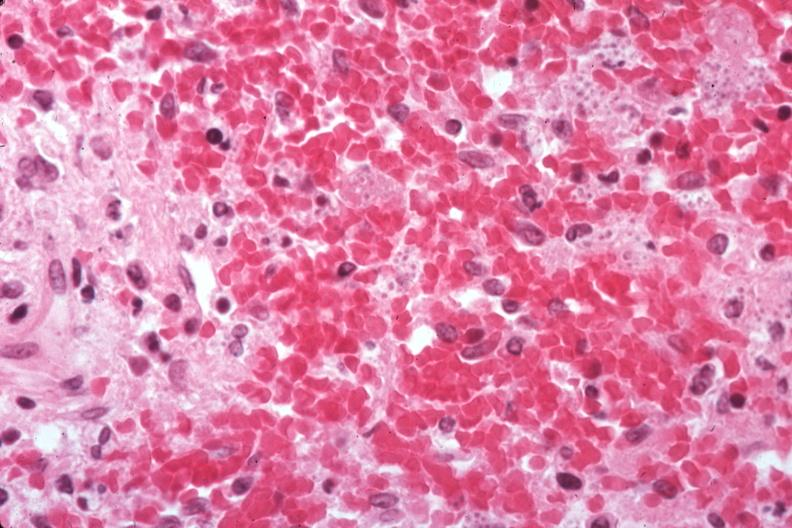what is present?
Answer the question using a single word or phrase. Histoplasmosis 